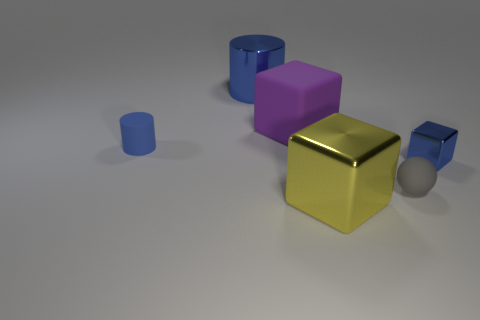Add 3 big brown shiny cylinders. How many objects exist? 9 Subtract all cylinders. How many objects are left? 4 Add 3 blue cylinders. How many blue cylinders exist? 5 Subtract 0 cyan blocks. How many objects are left? 6 Subtract all tiny spheres. Subtract all small blue matte cylinders. How many objects are left? 4 Add 3 blue blocks. How many blue blocks are left? 4 